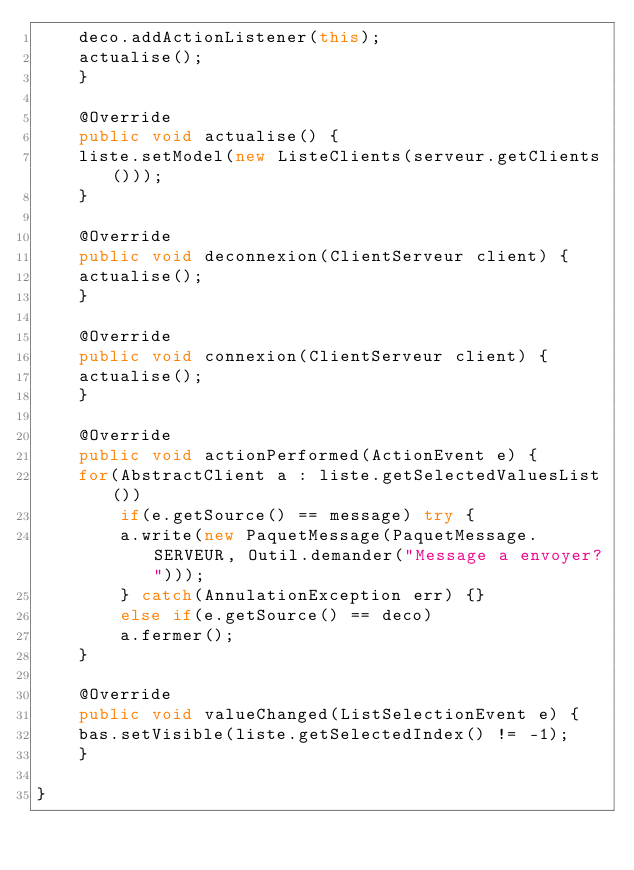<code> <loc_0><loc_0><loc_500><loc_500><_Java_>	deco.addActionListener(this);
	actualise();
    }

    @Override
    public void actualise() {
	liste.setModel(new ListeClients(serveur.getClients()));
    }

    @Override
    public void deconnexion(ClientServeur client) {
	actualise();
    }

    @Override
    public void connexion(ClientServeur client) {
	actualise();
    }

    @Override
    public void actionPerformed(ActionEvent e) {
	for(AbstractClient a : liste.getSelectedValuesList())
	    if(e.getSource() == message) try {
		a.write(new PaquetMessage(PaquetMessage.SERVEUR, Outil.demander("Message a envoyer?")));
	    } catch(AnnulationException err) {}
	    else if(e.getSource() == deco)
		a.fermer();
    }

    @Override
    public void valueChanged(ListSelectionEvent e) {
	bas.setVisible(liste.getSelectedIndex() != -1);
    }

}
</code> 